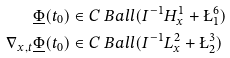<formula> <loc_0><loc_0><loc_500><loc_500>\underline { \Phi } ( t _ { 0 } ) & \in C \ B a l l ( I ^ { - 1 } H ^ { 1 } _ { x } + \L ^ { 6 } _ { 1 } ) \\ \nabla _ { x , t } \underline { \Phi } ( t _ { 0 } ) & \in C \ B a l l ( I ^ { - 1 } L ^ { 2 } _ { x } + \L ^ { 3 } _ { 2 } )</formula> 